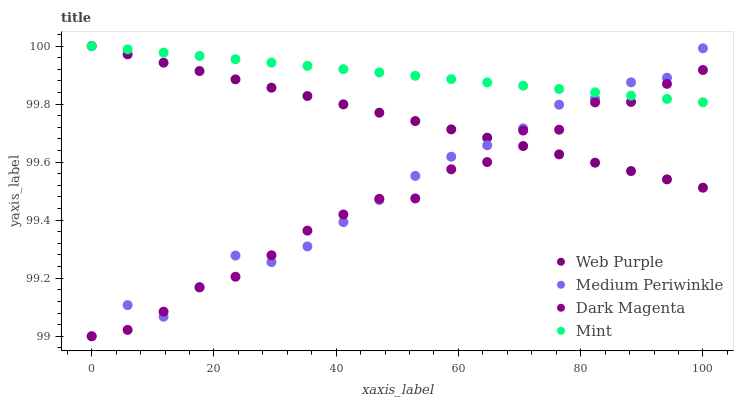Does Dark Magenta have the minimum area under the curve?
Answer yes or no. Yes. Does Mint have the maximum area under the curve?
Answer yes or no. Yes. Does Web Purple have the minimum area under the curve?
Answer yes or no. No. Does Web Purple have the maximum area under the curve?
Answer yes or no. No. Is Web Purple the smoothest?
Answer yes or no. Yes. Is Dark Magenta the roughest?
Answer yes or no. Yes. Is Medium Periwinkle the smoothest?
Answer yes or no. No. Is Medium Periwinkle the roughest?
Answer yes or no. No. Does Medium Periwinkle have the lowest value?
Answer yes or no. Yes. Does Web Purple have the lowest value?
Answer yes or no. No. Does Web Purple have the highest value?
Answer yes or no. Yes. Does Medium Periwinkle have the highest value?
Answer yes or no. No. Does Web Purple intersect Medium Periwinkle?
Answer yes or no. Yes. Is Web Purple less than Medium Periwinkle?
Answer yes or no. No. Is Web Purple greater than Medium Periwinkle?
Answer yes or no. No. 